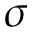<formula> <loc_0><loc_0><loc_500><loc_500>\sigma</formula> 